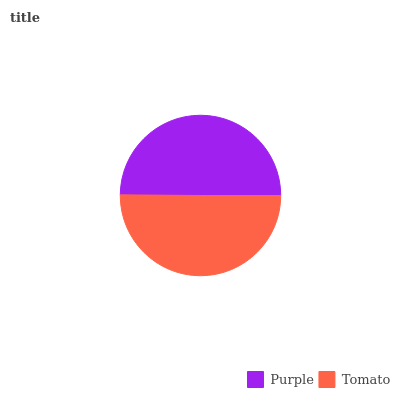Is Purple the minimum?
Answer yes or no. Yes. Is Tomato the maximum?
Answer yes or no. Yes. Is Tomato the minimum?
Answer yes or no. No. Is Tomato greater than Purple?
Answer yes or no. Yes. Is Purple less than Tomato?
Answer yes or no. Yes. Is Purple greater than Tomato?
Answer yes or no. No. Is Tomato less than Purple?
Answer yes or no. No. Is Tomato the high median?
Answer yes or no. Yes. Is Purple the low median?
Answer yes or no. Yes. Is Purple the high median?
Answer yes or no. No. Is Tomato the low median?
Answer yes or no. No. 